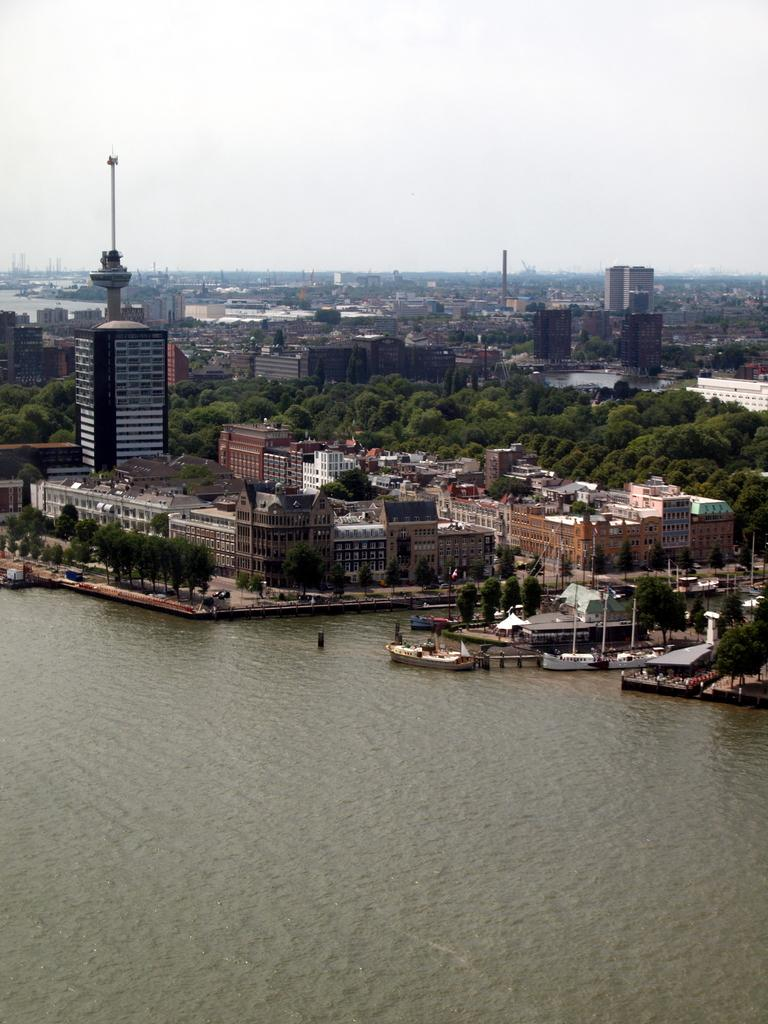What type of natural feature is present in the image? There is a river in the image. What man-made structures can be seen in the image? There are buildings in the image. What type of vegetation is visible in the background of the image? There are trees in the background of the image. What is the condition of the sky in the image? The sky is clear and visible at the top of the image. What type of plastic material can be seen floating in the river in the image? There is no plastic material visible in the river in the image. Can you hear anyone coughing in the image? There is no sound present in the image, so it is not possible to hear anyone coughing. 